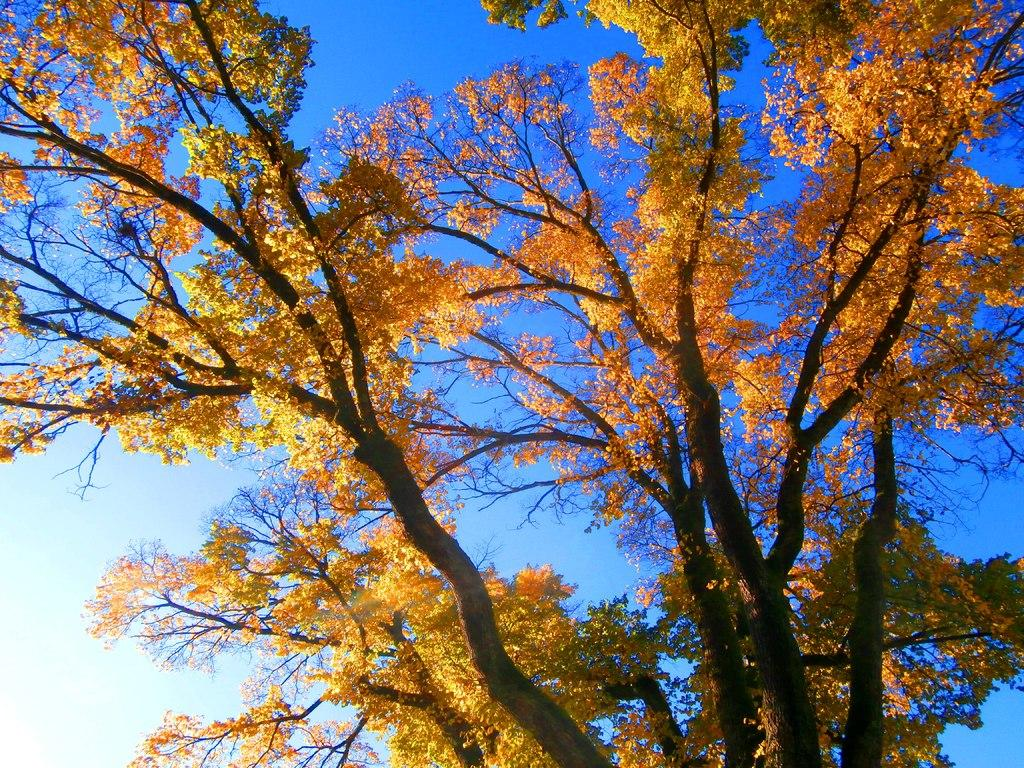What is located in the foreground of the image? There is a tree in the foreground of the image. What can be seen in the background of the image? The sky is visible in the background of the image. What type of fiction is the tree reading in the image? There is no indication in the image that the tree is reading any fiction, as trees do not have the ability to read. 